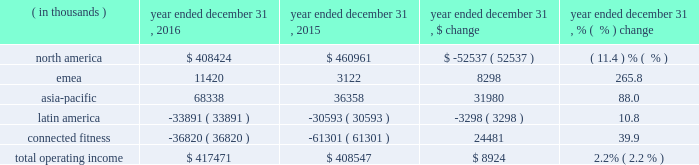Operating income ( loss ) by segment is summarized below: .
The increase in total operating income was driven by the following : 2022 operating income in our north america operating segment decreased $ 52.5 million to $ 408.4 million in 2016 from $ 461.0 million in 2015 primarily due to decreases in gross margin discussed above in the consolidated results of operations and $ 17.0 million in expenses related to the liquidation of the sports authority , comprised of $ 15.2 million in bad debt expense and $ 1.8 million of in-store fixture impairment .
In addition , this decrease reflects the movement of $ 11.1 million in expenses resulting from a strategic shift in headcount supporting our global business from our connected fitness operating segment to north america .
This decrease is partially offset by the increases in revenue discussed above in the consolidated results of operations .
2022 operating income in our emea operating segment increased $ 8.3 million to $ 11.4 million in 2016 from $ 3.1 million in 2015 primarily due to sales growth discussed above and reductions in incentive compensation .
This increase was offset by investments in sports marketing and infrastructure for future growth .
2022 operating income in our asia-pacific operating segment increased $ 31.9 million to $ 68.3 million in 2016 from $ 36.4 million in 2015 primarily due to sales growth discussed above and reductions in incentive compensation .
This increase was offset by investments in our direct-to-consumer business and entry into new territories .
2022 operating loss in our latin america operating segment increased $ 3.3 million to $ 33.9 million in 2016 from $ 30.6 million in 2015 primarily due to increased investments to support growth in the region and the economic challenges in brazil during the period .
This increase in operating loss was offset by sales growth discussed above and reductions in incentive compensation .
2022 operating loss in our connected fitness segment decreased $ 24.5 million to $ 36.8 million in 2016 from $ 61.3 million in 2015 primarily driven by sales growth discussed above .
Seasonality historically , we have recognized a majority of our net revenues and a significant portion of our income from operations in the last two quarters of the year , driven primarily by increased sales volume of our products during the fall selling season , including our higher priced cold weather products , along with a larger proportion of higher margin direct to consumer sales .
The level of our working capital generally reflects the seasonality and growth in our business .
We generally expect inventory , accounts payable and certain accrued expenses to be higher in the second and third quarters in preparation for the fall selling season. .
What portion of total operating income is generated by north america segment in 2015? 
Computations: (460961 / 408547)
Answer: 1.12829. 